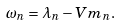<formula> <loc_0><loc_0><loc_500><loc_500>\omega _ { n } = \lambda _ { n } - V m _ { n } .</formula> 